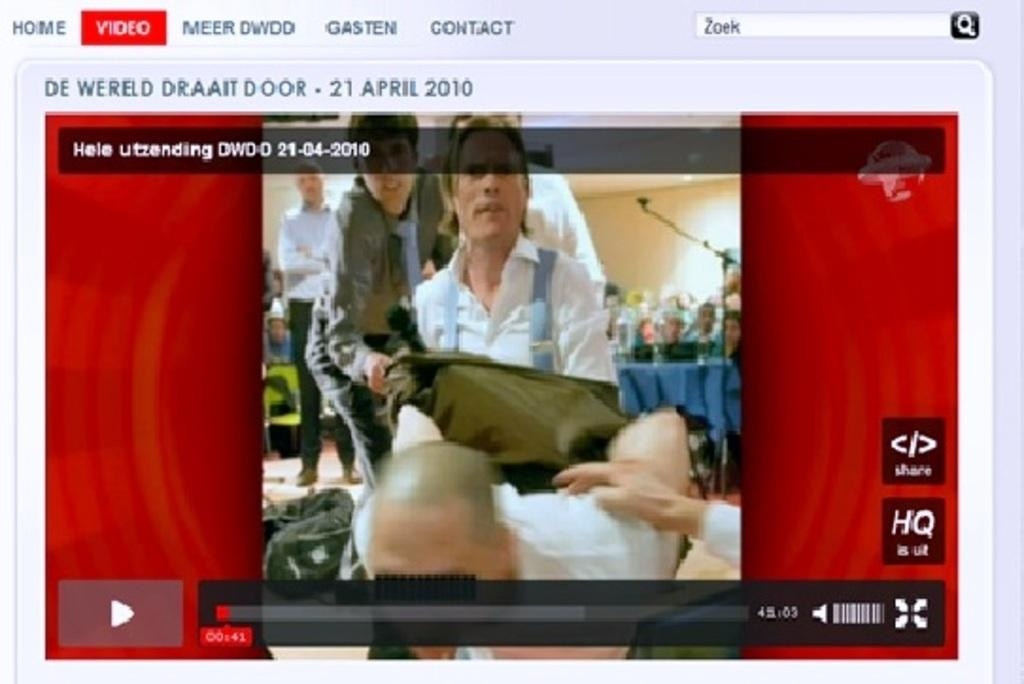<image>
Summarize the visual content of the image. A computer window shows a red tab with "video" on it. 